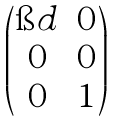<formula> <loc_0><loc_0><loc_500><loc_500>\begin{pmatrix} \i d & 0 \\ 0 & 0 \\ 0 & 1 \end{pmatrix}</formula> 